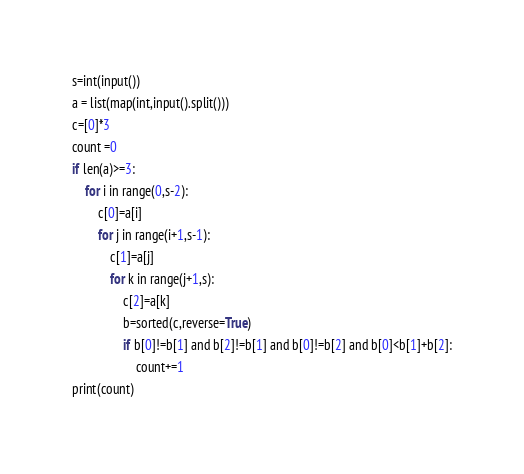<code> <loc_0><loc_0><loc_500><loc_500><_Python_>s=int(input())
a = list(map(int,input().split()))
c=[0]*3
count =0
if len(a)>=3:
    for i in range(0,s-2):
        c[0]=a[i]
        for j in range(i+1,s-1):
            c[1]=a[j]
            for k in range(j+1,s):
                c[2]=a[k]
                b=sorted(c,reverse=True)
                if b[0]!=b[1] and b[2]!=b[1] and b[0]!=b[2] and b[0]<b[1]+b[2]:
                    count+=1
print(count)</code> 